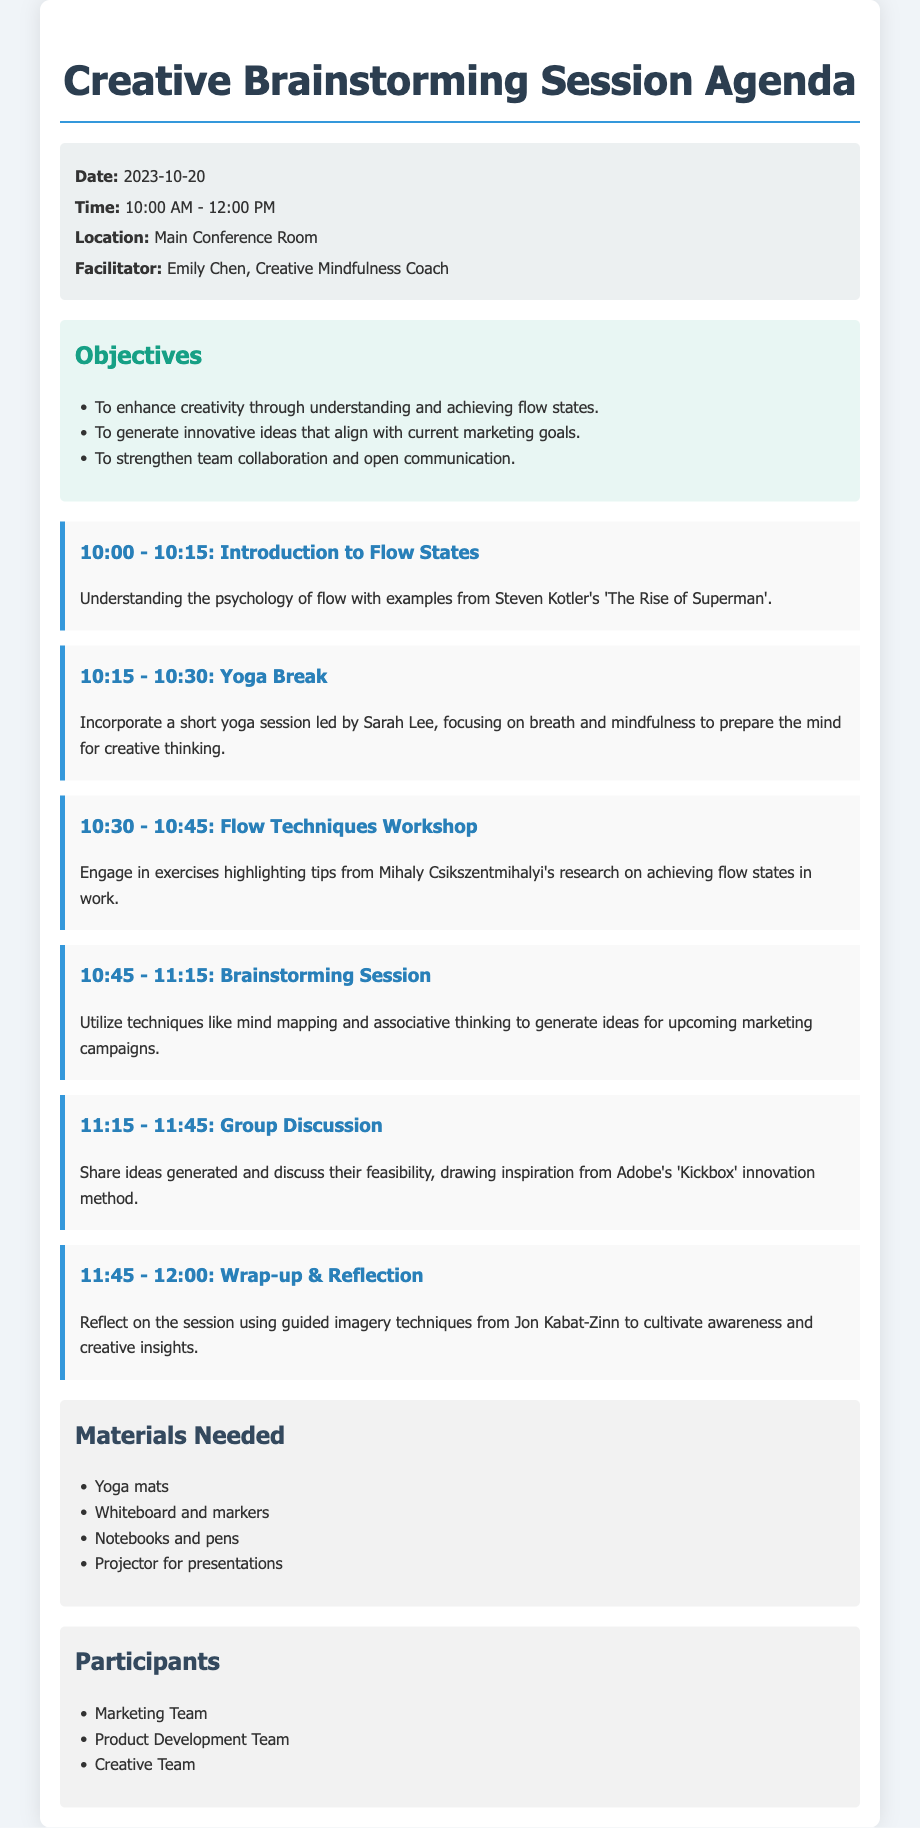What is the date of the session? The date of the session is specified in the information section of the document.
Answer: 2023-10-20 Who is the facilitator of the session? The facilitator's name is listed in the information section under "Facilitator".
Answer: Emily Chen What is the duration of the yoga break? The yoga break duration can be found in the agenda items where each time slot is defined.
Answer: 15 minutes What technique will be used for the brainstorming session? The techniques for the brainstorming session are mentioned in the corresponding agenda item.
Answer: Mind mapping What is one objective of the session? One of the objectives is listed in the objectives section of the document.
Answer: To enhance creativity through understanding and achieving flow states At what time does the wrap-up and reflection occur? The wrap-up and reflection timing is detailed in the agenda section of the document.
Answer: 12:00 PM What materials are needed for the session? The necessary materials are listed in the materials section of the document.
Answer: Yoga mats Which team is listed as a participant? The list of participants includes several teams mentioned in the participants section.
Answer: Marketing Team What is the location of the session? The location is provided in the information section of the document.
Answer: Main Conference Room 